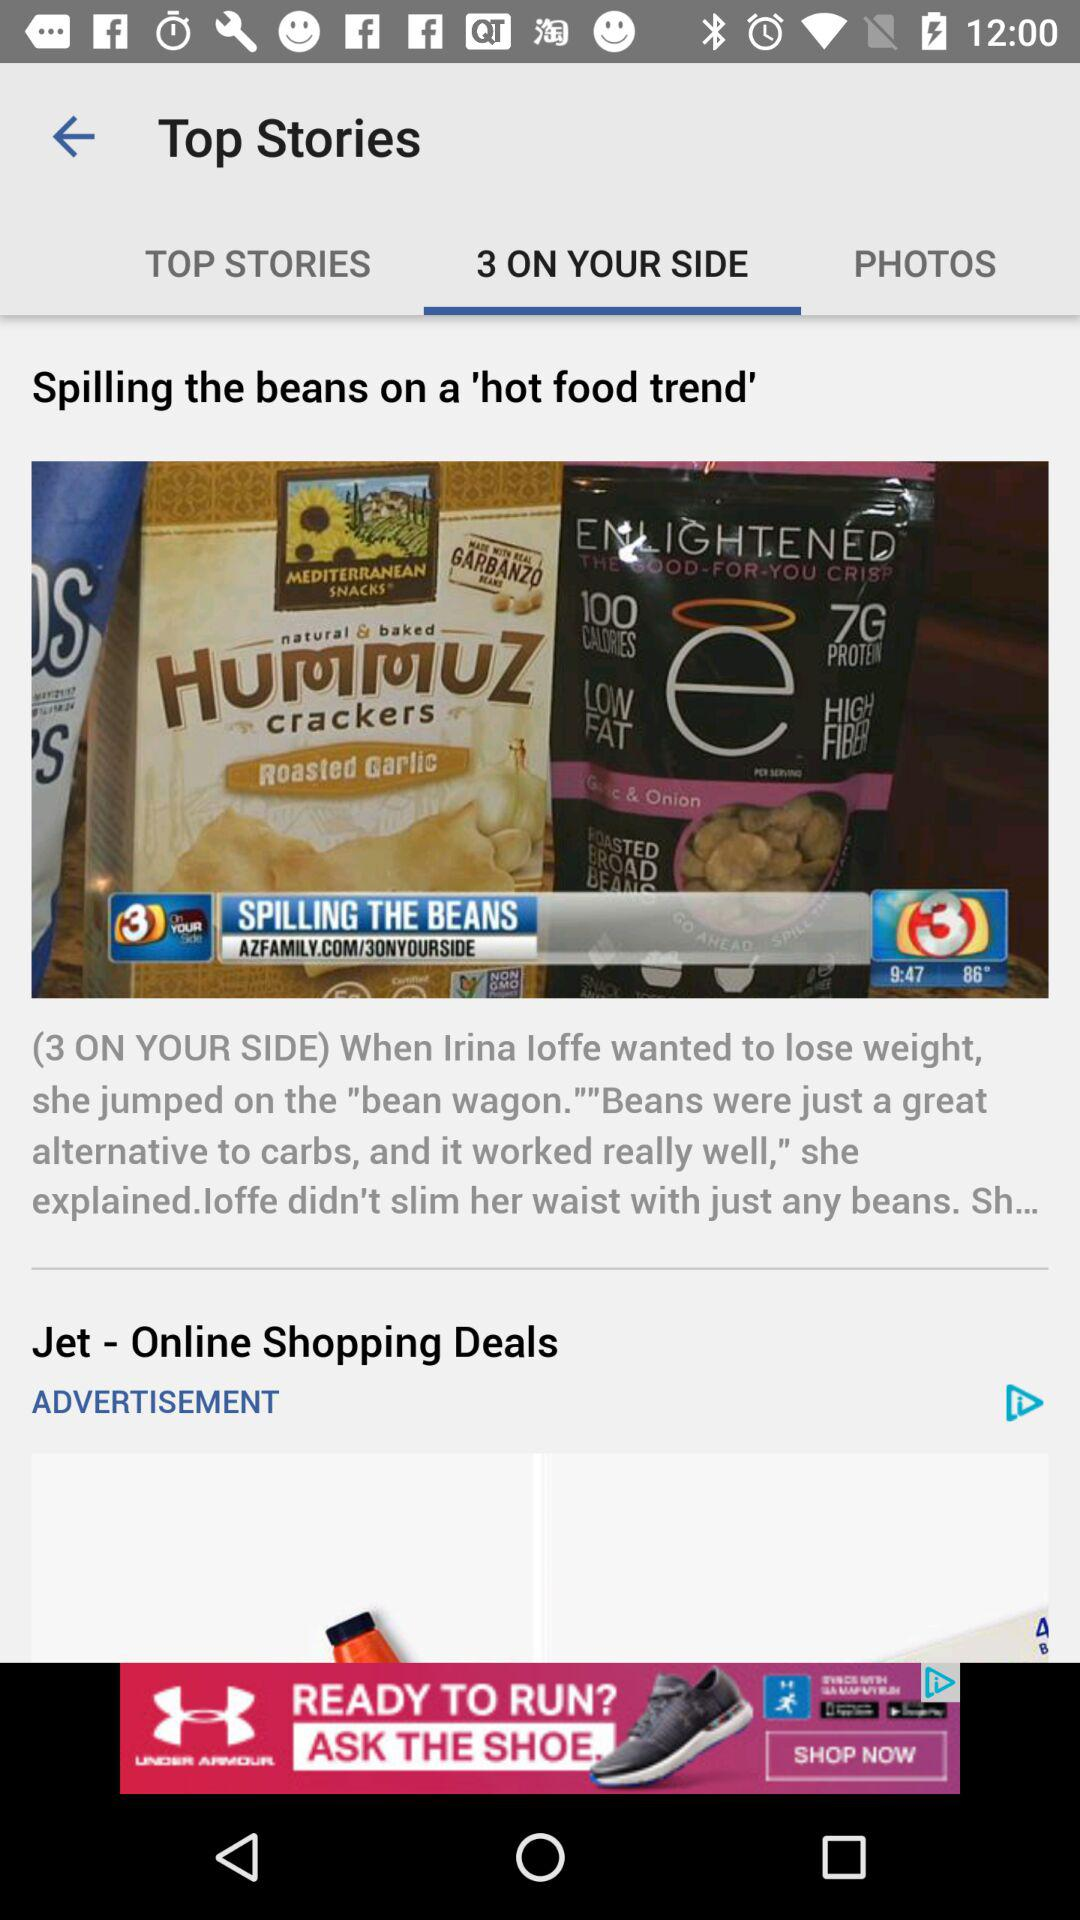Which option is selected in "Top Stories"? The selected option is "3 ON YOUR SIDE". 